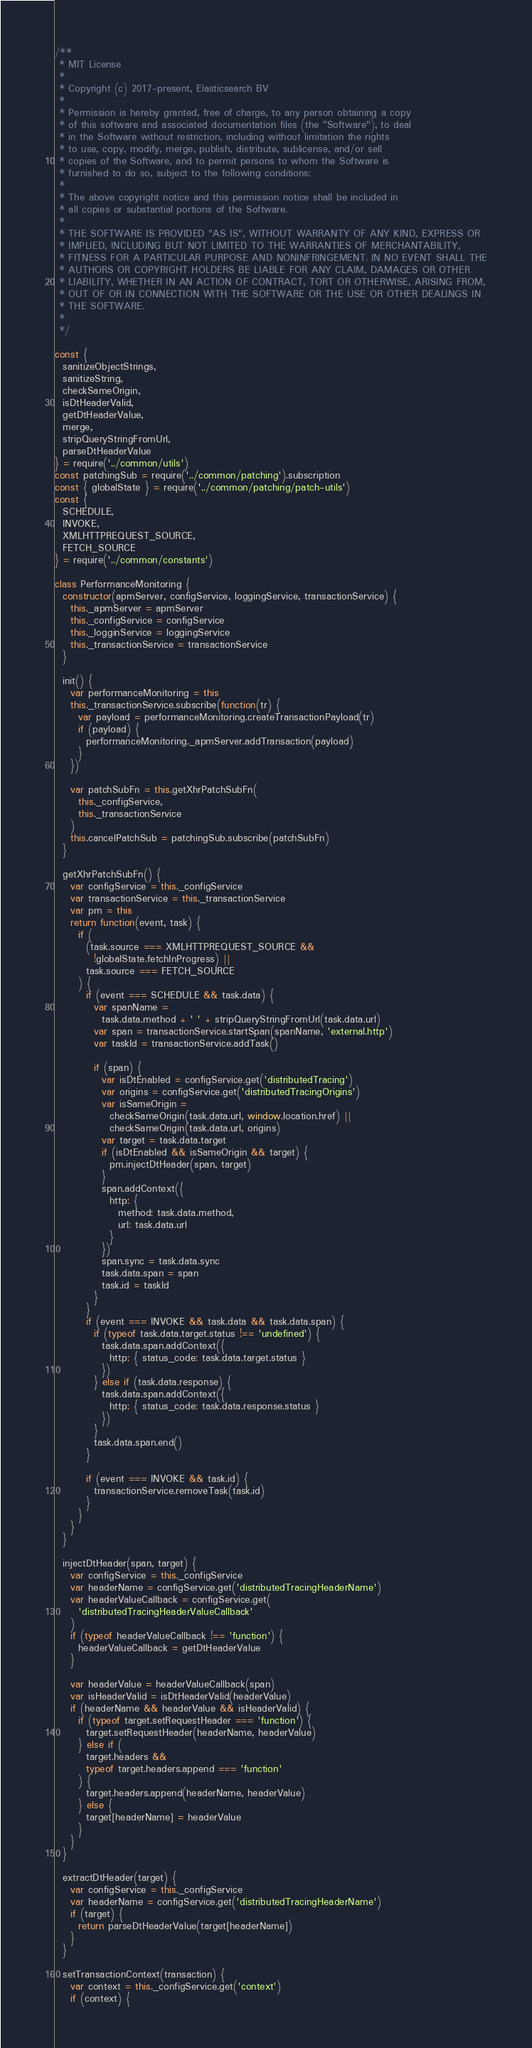Convert code to text. <code><loc_0><loc_0><loc_500><loc_500><_JavaScript_>/**
 * MIT License
 *
 * Copyright (c) 2017-present, Elasticsearch BV
 *
 * Permission is hereby granted, free of charge, to any person obtaining a copy
 * of this software and associated documentation files (the "Software"), to deal
 * in the Software without restriction, including without limitation the rights
 * to use, copy, modify, merge, publish, distribute, sublicense, and/or sell
 * copies of the Software, and to permit persons to whom the Software is
 * furnished to do so, subject to the following conditions:
 *
 * The above copyright notice and this permission notice shall be included in
 * all copies or substantial portions of the Software.
 *
 * THE SOFTWARE IS PROVIDED "AS IS", WITHOUT WARRANTY OF ANY KIND, EXPRESS OR
 * IMPLIED, INCLUDING BUT NOT LIMITED TO THE WARRANTIES OF MERCHANTABILITY,
 * FITNESS FOR A PARTICULAR PURPOSE AND NONINFRINGEMENT. IN NO EVENT SHALL THE
 * AUTHORS OR COPYRIGHT HOLDERS BE LIABLE FOR ANY CLAIM, DAMAGES OR OTHER
 * LIABILITY, WHETHER IN AN ACTION OF CONTRACT, TORT OR OTHERWISE, ARISING FROM,
 * OUT OF OR IN CONNECTION WITH THE SOFTWARE OR THE USE OR OTHER DEALINGS IN
 * THE SOFTWARE.
 *
 */

const {
  sanitizeObjectStrings,
  sanitizeString,
  checkSameOrigin,
  isDtHeaderValid,
  getDtHeaderValue,
  merge,
  stripQueryStringFromUrl,
  parseDtHeaderValue
} = require('../common/utils')
const patchingSub = require('../common/patching').subscription
const { globalState } = require('../common/patching/patch-utils')
const {
  SCHEDULE,
  INVOKE,
  XMLHTTPREQUEST_SOURCE,
  FETCH_SOURCE
} = require('../common/constants')

class PerformanceMonitoring {
  constructor(apmServer, configService, loggingService, transactionService) {
    this._apmServer = apmServer
    this._configService = configService
    this._logginService = loggingService
    this._transactionService = transactionService
  }

  init() {
    var performanceMonitoring = this
    this._transactionService.subscribe(function(tr) {
      var payload = performanceMonitoring.createTransactionPayload(tr)
      if (payload) {
        performanceMonitoring._apmServer.addTransaction(payload)
      }
    })

    var patchSubFn = this.getXhrPatchSubFn(
      this._configService,
      this._transactionService
    )
    this.cancelPatchSub = patchingSub.subscribe(patchSubFn)
  }

  getXhrPatchSubFn() {
    var configService = this._configService
    var transactionService = this._transactionService
    var pm = this
    return function(event, task) {
      if (
        (task.source === XMLHTTPREQUEST_SOURCE &&
          !globalState.fetchInProgress) ||
        task.source === FETCH_SOURCE
      ) {
        if (event === SCHEDULE && task.data) {
          var spanName =
            task.data.method + ' ' + stripQueryStringFromUrl(task.data.url)
          var span = transactionService.startSpan(spanName, 'external.http')
          var taskId = transactionService.addTask()

          if (span) {
            var isDtEnabled = configService.get('distributedTracing')
            var origins = configService.get('distributedTracingOrigins')
            var isSameOrigin =
              checkSameOrigin(task.data.url, window.location.href) ||
              checkSameOrigin(task.data.url, origins)
            var target = task.data.target
            if (isDtEnabled && isSameOrigin && target) {
              pm.injectDtHeader(span, target)
            }
            span.addContext({
              http: {
                method: task.data.method,
                url: task.data.url
              }
            })
            span.sync = task.data.sync
            task.data.span = span
            task.id = taskId
          }
        }
        if (event === INVOKE && task.data && task.data.span) {
          if (typeof task.data.target.status !== 'undefined') {
            task.data.span.addContext({
              http: { status_code: task.data.target.status }
            })
          } else if (task.data.response) {
            task.data.span.addContext({
              http: { status_code: task.data.response.status }
            })
          }
          task.data.span.end()
        }

        if (event === INVOKE && task.id) {
          transactionService.removeTask(task.id)
        }
      }
    }
  }

  injectDtHeader(span, target) {
    var configService = this._configService
    var headerName = configService.get('distributedTracingHeaderName')
    var headerValueCallback = configService.get(
      'distributedTracingHeaderValueCallback'
    )
    if (typeof headerValueCallback !== 'function') {
      headerValueCallback = getDtHeaderValue
    }

    var headerValue = headerValueCallback(span)
    var isHeaderValid = isDtHeaderValid(headerValue)
    if (headerName && headerValue && isHeaderValid) {
      if (typeof target.setRequestHeader === 'function') {
        target.setRequestHeader(headerName, headerValue)
      } else if (
        target.headers &&
        typeof target.headers.append === 'function'
      ) {
        target.headers.append(headerName, headerValue)
      } else {
        target[headerName] = headerValue
      }
    }
  }

  extractDtHeader(target) {
    var configService = this._configService
    var headerName = configService.get('distributedTracingHeaderName')
    if (target) {
      return parseDtHeaderValue(target[headerName])
    }
  }

  setTransactionContext(transaction) {
    var context = this._configService.get('context')
    if (context) {</code> 